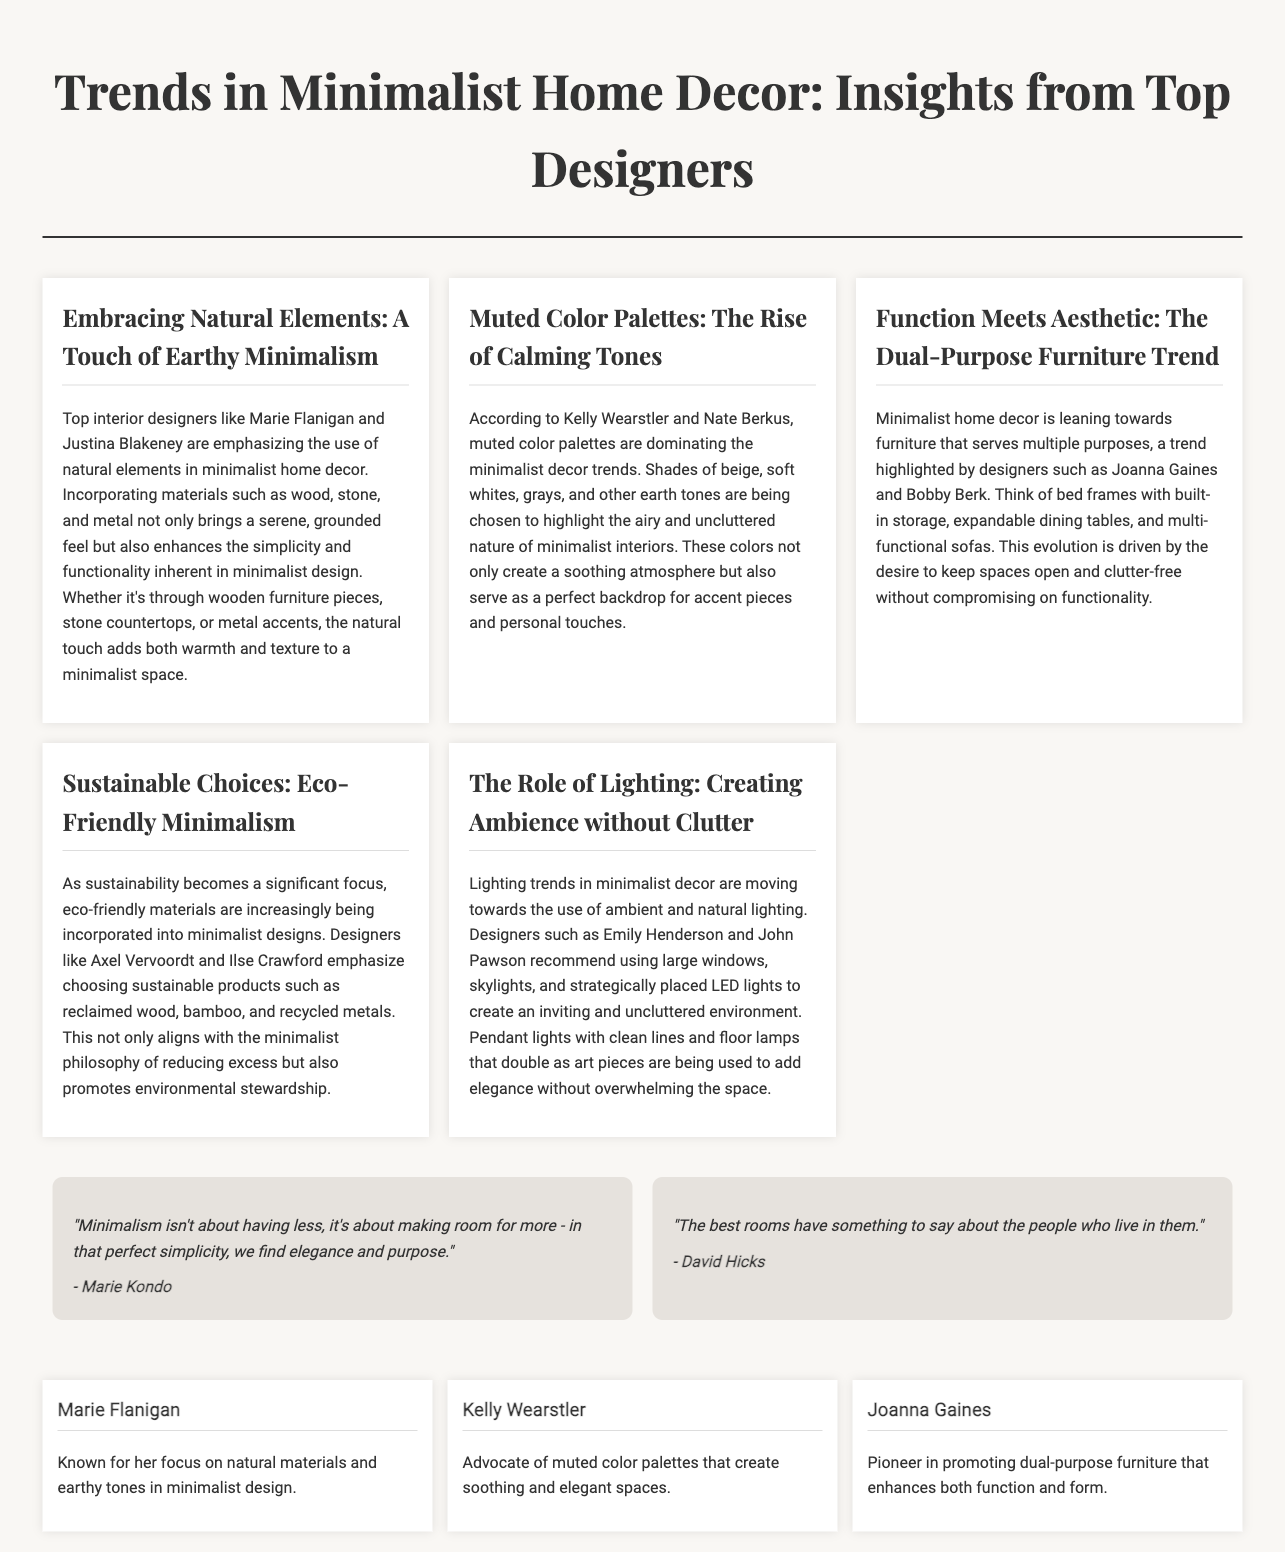What is the primary focus of minimalist home decor according to the document? The document highlights the focus on natural elements, muted color palettes, dual-purpose furniture, sustainable choices, and the role of lighting in minimalist home decor.
Answer: Natural elements Who are the designers mentioned as emphasizing muted color palettes? The document lists Kelly Wearstler and Nate Berkus as designers who advocate for muted color palettes in minimalist decor.
Answer: Kelly Wearstler and Nate Berkus What kind of trends do Joanna Gaines and Bobby Berk promote? Joanna Gaines and Bobby Berk are noted for promoting furniture that serves multiple purposes, a key trend in minimalist home decor.
Answer: Dual-purpose furniture What materials are suggested for sustainable choices in minimalism? The document mentions reclaimed wood, bamboo, and recycled metals as eco-friendly materials being used in minimalist designs.
Answer: Reclaimed wood, bamboo, and recycled metals Which designer is known for advocating ambient lighting? The document cites Emily Henderson and John Pawson as designers who recommend the use of ambient and natural lighting in minimalist decor.
Answer: Emily Henderson and John Pawson 